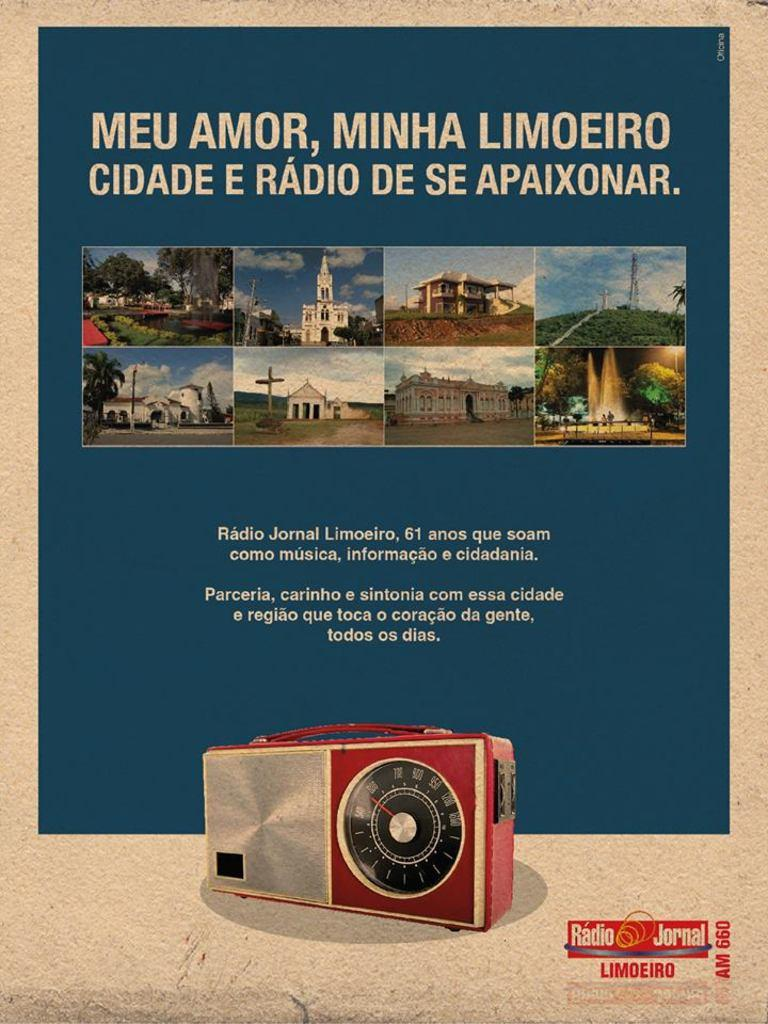What is the main object in the image? There is a pamphlet in the image. What can be seen on the pamphlet? There is writing on the pamphlet in white color. What else is visible in the image besides the pamphlet? There are buildings and a radio visible in the image. What type of ice can be seen melting on the user's toe in the image? There is no ice or user's toe present in the image. What belief system is being promoted in the image? The image does not show any specific belief system being promoted. 